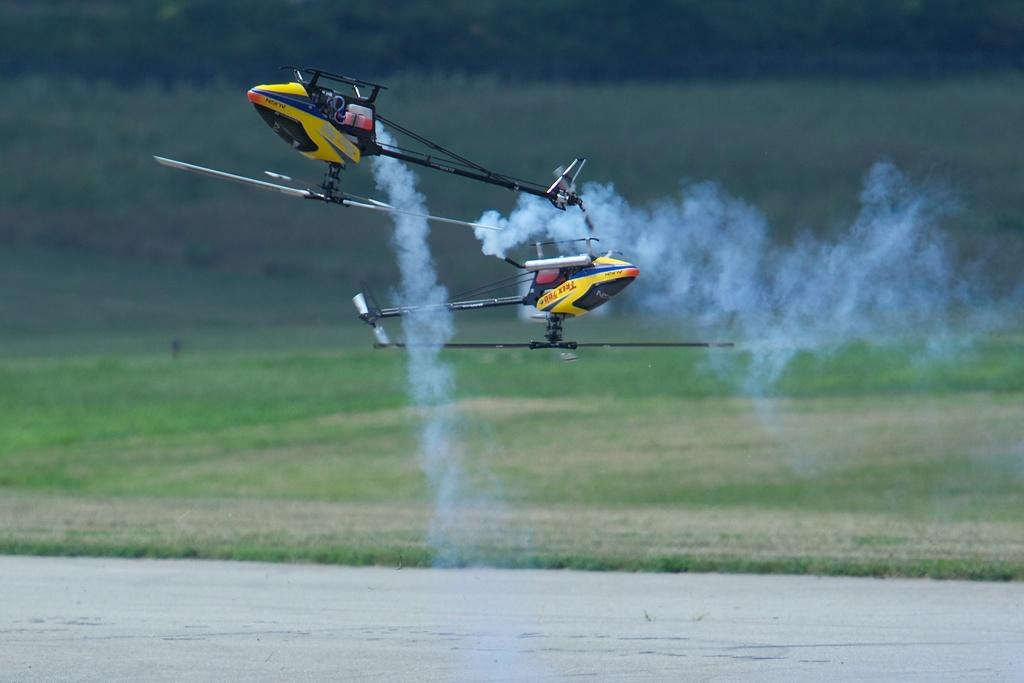What type of vehicles are present in the image? There are helicopters in the image. What is coming out from the helicopters? Smoke is coming out from the helicopters. What is the condition of the land in the image? The land in the image is covered with grass. What type of dirt can be seen on the ground in the image? There is no dirt visible on the ground in the image; the land is covered with grass. What type of gun can be seen in the hands of the people in the image? There are no people or guns present in the image; it features helicopters and smoke. 